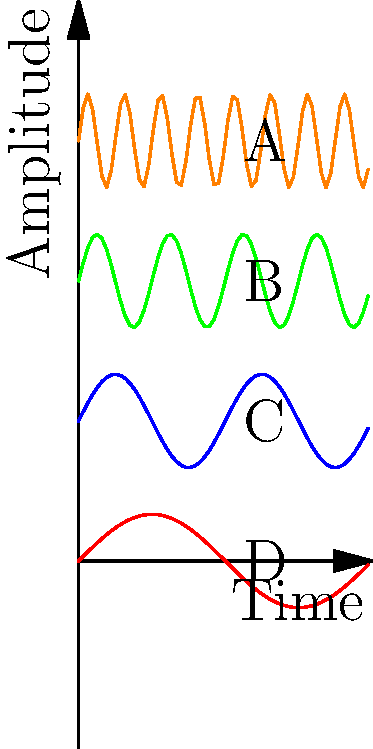As a musician who appreciates the intricacies of sound, imagine you're analyzing audio waveforms on an oscilloscope. The image shows four different waveforms (A, B, C, and D) representing various audio signals. Which waveform would most likely correspond to Marina's high-pitched, crystal-clear vocals in her song "Primadonna"? To answer this question, let's analyze each waveform:

1. Waveform A (Orange): This has the highest frequency among the four, with 8 complete cycles within the given time frame. High-frequency waves correspond to higher pitches in audio.

2. Waveform B (Green): This has the second-highest frequency, with 4 complete cycles. It represents a moderately high pitch.

3. Waveform C (Blue): This has 2 complete cycles, representing a lower pitch compared to A and B.

4. Waveform D (Red): This has the lowest frequency, with only 1 complete cycle. It represents the lowest pitch among the four.

In audio engineering, higher frequencies correspond to higher pitches. Marina's vocals in "Primadonna" are known for their high-pitched, crystal-clear quality. Therefore, the waveform that would most likely represent her vocals would be the one with the highest frequency.

Among the given waveforms, Waveform A (Orange) has the highest frequency and would best represent Marina's high-pitched vocals.
Answer: Waveform A 